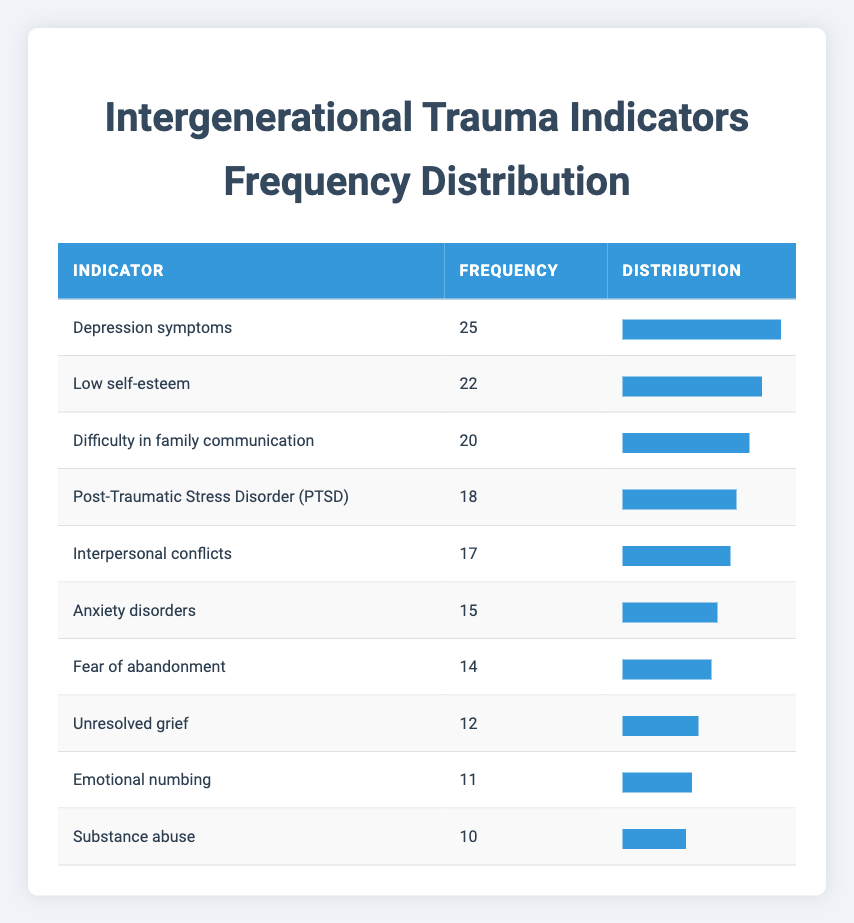What is the frequency of Depression symptoms? The frequency column shows that Depression symptoms have a reported frequency of 25.
Answer: 25 How many family assessments reported Anxiety disorders? The frequency for Anxiety disorders is listed as 15 in the table.
Answer: 15 What is the sum of frequencies for Interpersonal conflicts and Emotional numbing? The frequency for Interpersonal conflicts is 17 and for Emotional numbing is 11. Adding these together: 17 + 11 = 28.
Answer: 28 Is the frequency of Substance abuse higher than that of Unresolved grief? Substance abuse has a frequency of 10 and Unresolved grief has a frequency of 12. Since 10 is not higher than 12, the statement is false.
Answer: No What is the average frequency of all the trauma indicators listed? The total frequency is calculated by adding all the frequencies: 15 + 25 + 10 + 18 + 20 + 12 + 22 + 14 + 11 + 17 =  174. There are 10 indicators, so the average is 174/10 = 17.4.
Answer: 17.4 What is the difference between the highest and lowest frequency values? The highest frequency is 25 (Depression symptoms) and the lowest frequency is 10 (Substance abuse). The difference is calculated as 25 - 10 = 15.
Answer: 15 Which trauma indicator has the second highest frequency? The indicators ranked by frequency are: 1) Depression symptoms (25), 2) Low self-esteem (22), 3) Difficulty in family communication (20), therefore, Low self-esteem has the second highest frequency at 22.
Answer: Low self-esteem Are more than half of the indicators reported to have a frequency greater than 15? The indicators with a frequency greater than 15 are Depression symptoms, Low self-esteem, Difficulty in family communication, PTSD, and Interpersonal conflicts. That's 5 out of 10 indicators, which is exactly half, so the answer is false.
Answer: No 